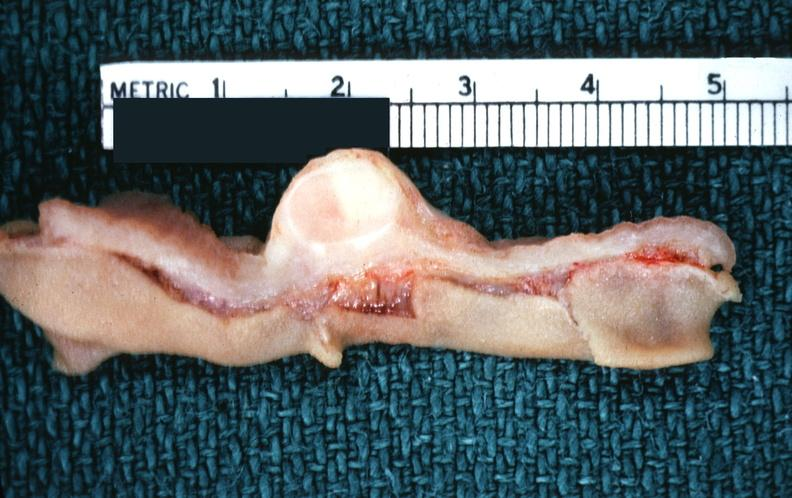what does this image show?
Answer the question using a single word or phrase. Stomach 